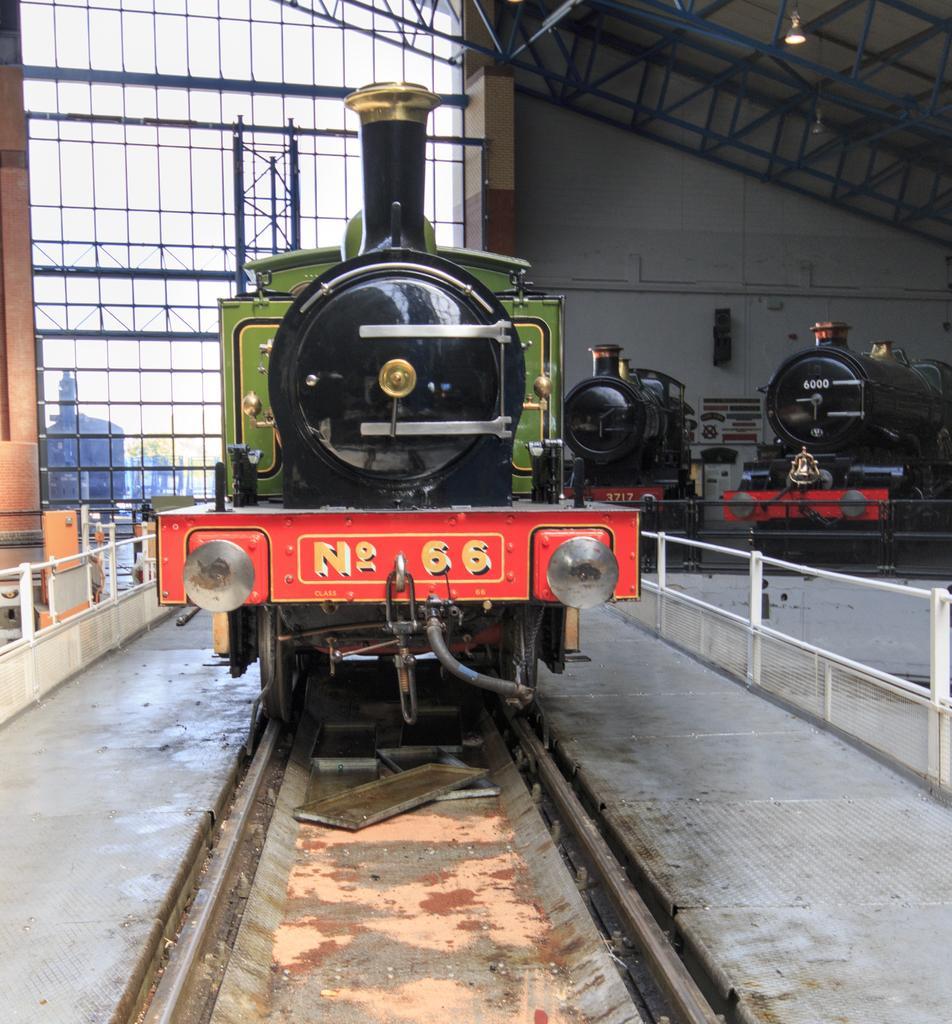In one or two sentences, can you explain what this image depicts? In this picture we can see a train on a railway track and in the background we can see trains, fences, poles, glass, light and some objects. 